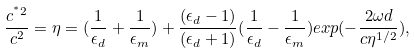<formula> <loc_0><loc_0><loc_500><loc_500>\frac { c ^ { ^ { * } 2 } } { c ^ { 2 } } = \eta = ( \frac { 1 } { \epsilon _ { d } } + \frac { 1 } { \epsilon _ { m } } ) + \frac { ( \epsilon _ { d } - 1 ) } { ( \epsilon _ { d } + 1 ) } ( \frac { 1 } { \epsilon _ { d } } - \frac { 1 } { \epsilon _ { m } } ) e x p ( - \frac { 2 \omega d } { c \eta ^ { 1 / 2 } } ) ,</formula> 